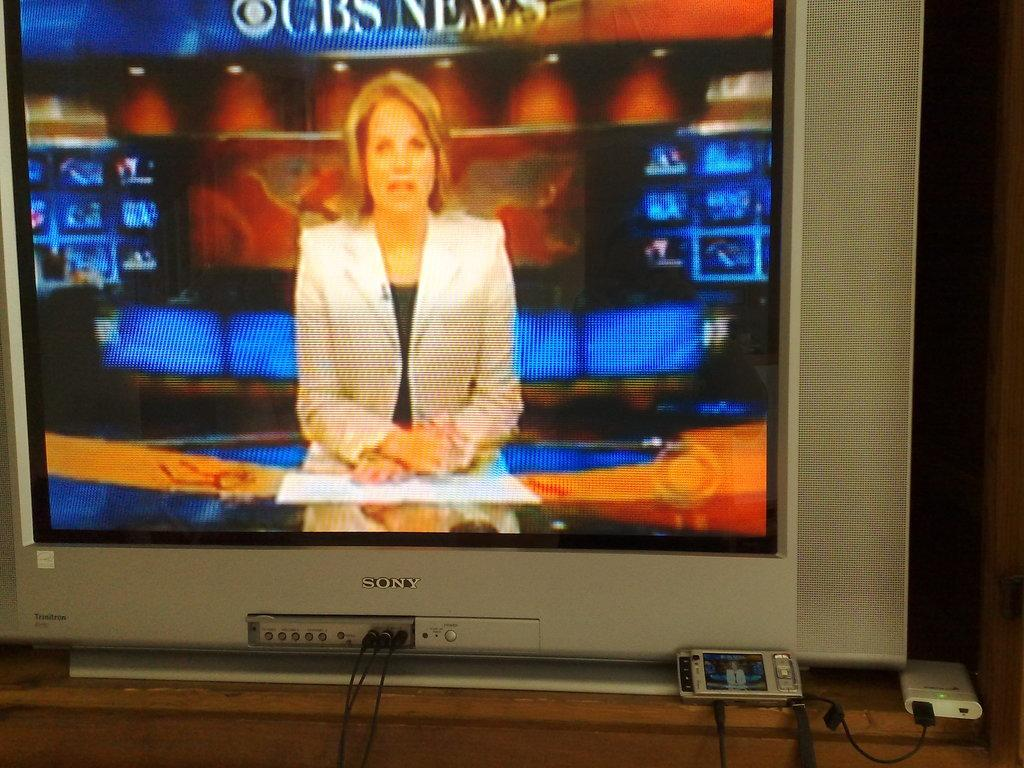<image>
Present a compact description of the photo's key features. A female, CBS  News caster is on the screen of an older, tube television. 